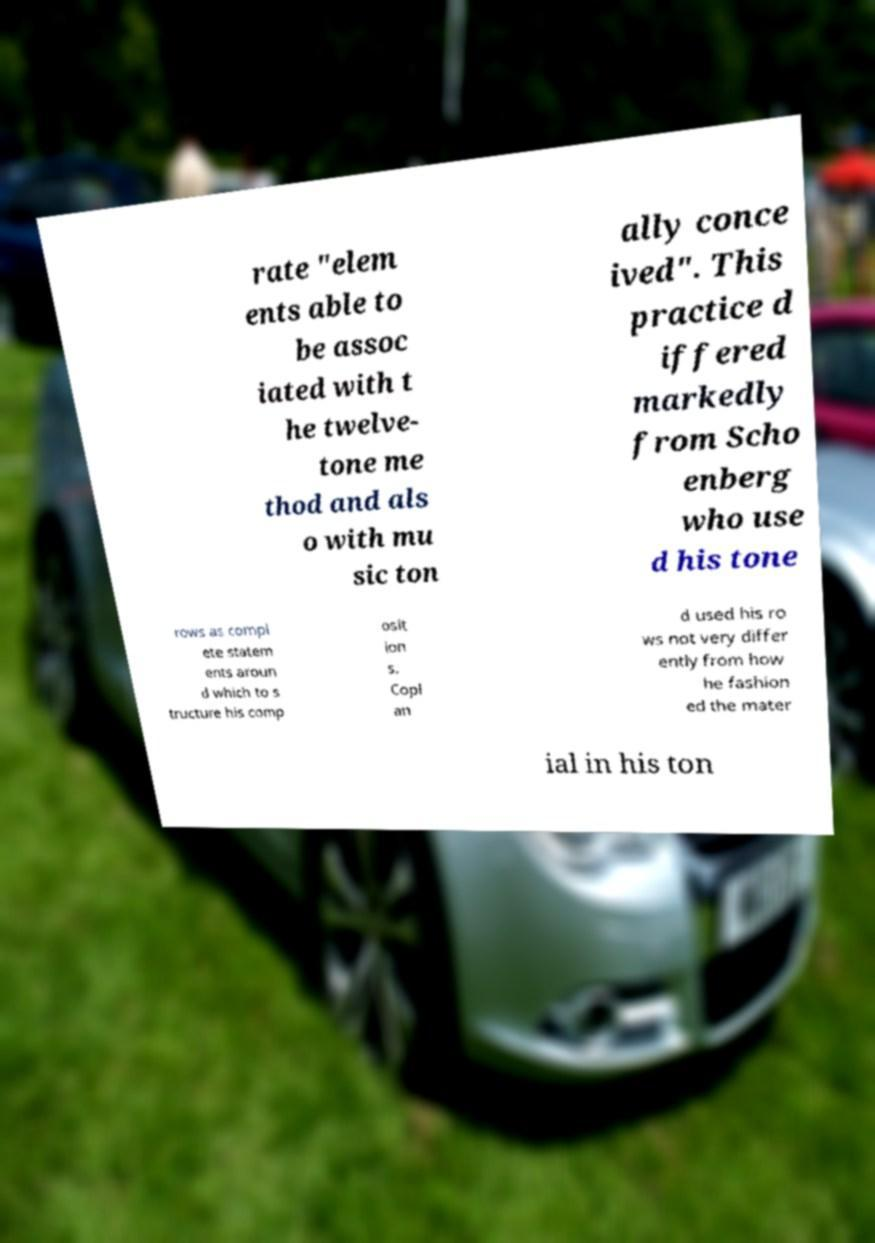Can you accurately transcribe the text from the provided image for me? rate "elem ents able to be assoc iated with t he twelve- tone me thod and als o with mu sic ton ally conce ived". This practice d iffered markedly from Scho enberg who use d his tone rows as compl ete statem ents aroun d which to s tructure his comp osit ion s. Copl an d used his ro ws not very differ ently from how he fashion ed the mater ial in his ton 